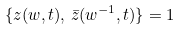<formula> <loc_0><loc_0><loc_500><loc_500>\{ z ( w , t ) , \, \bar { z } ( w ^ { - 1 } , t ) \} = 1</formula> 